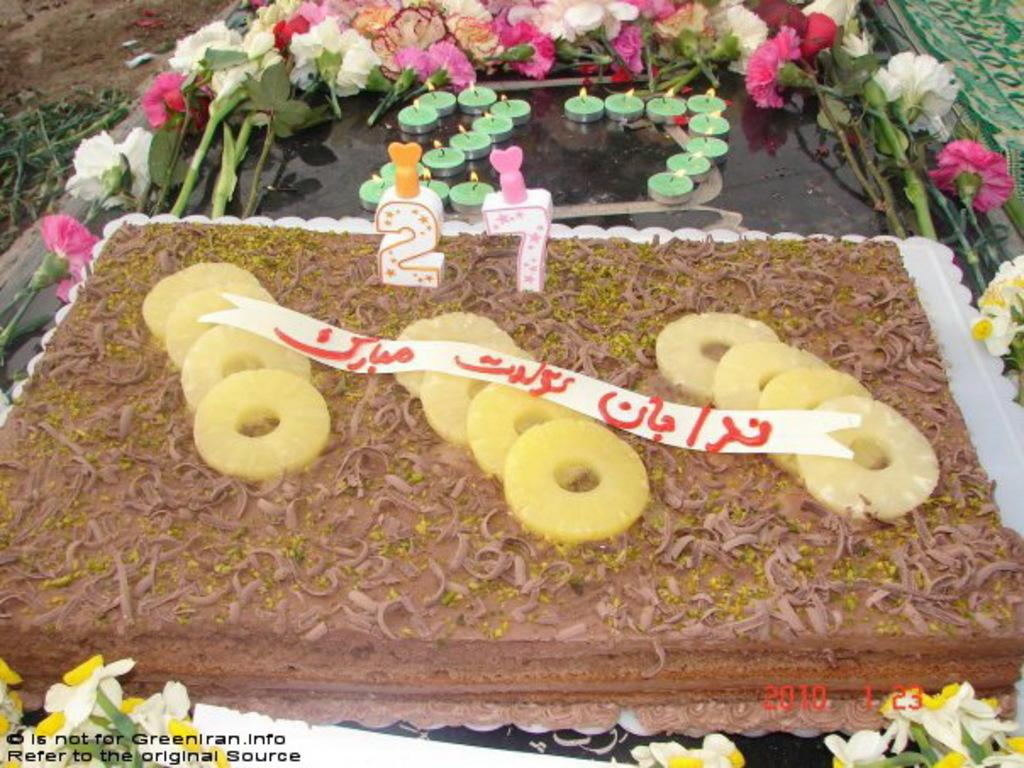What is the main subject of the image? There is a cake in the image. What is placed on or around the cake? There are candles and flowers in the image. On what surface are the cake and other objects likely placed? The objects mentioned are likely on a table or similar surface. What can be seen at the bottom of the image? There are watermarks at the bottom of the image. What type of vegetation is visible in the top left corner of the image? There are plants visible in the top left corner of the image. What type of cream is being used by the actor in the image? There is no actor or cream present in the image; it features a cake with candles and flowers. 